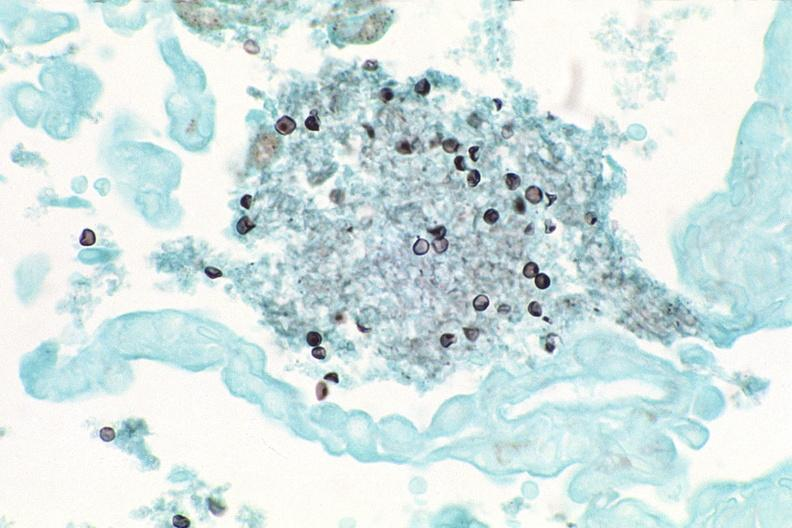do silver stain?
Answer the question using a single word or phrase. Yes 